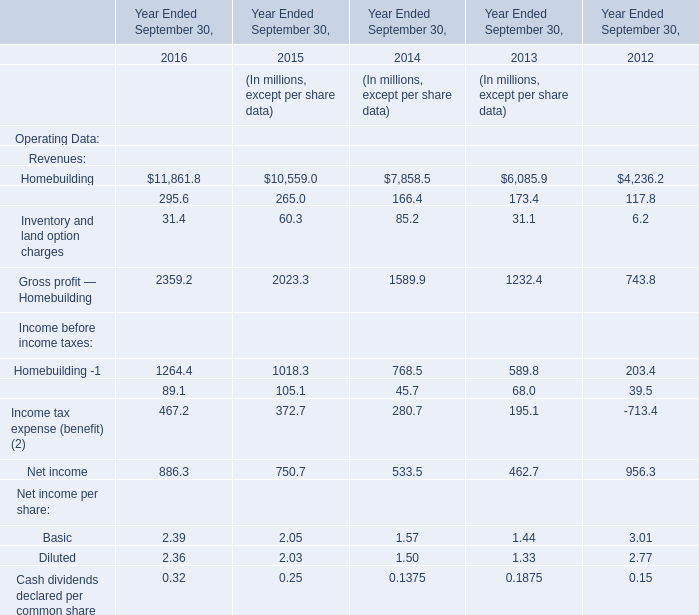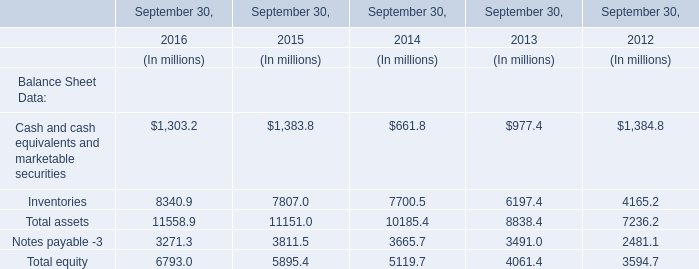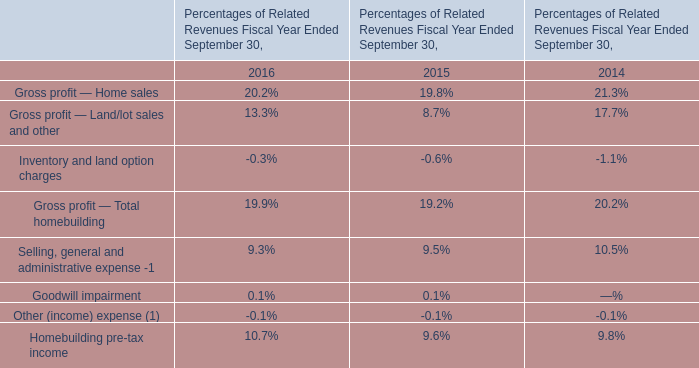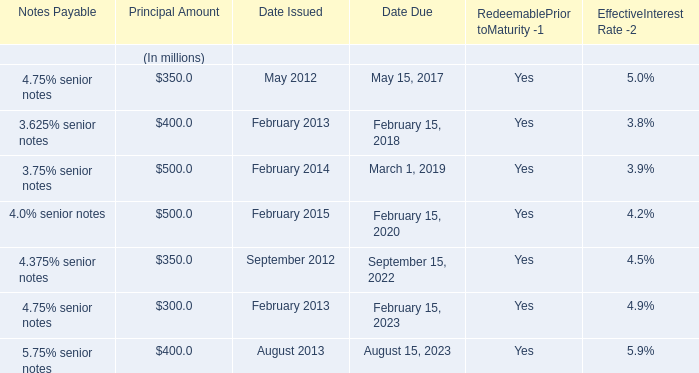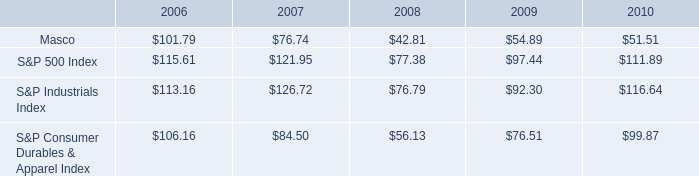what was the difference in percentage cumulative total shareholder return on masco common stock versus the s&p 500 index for the five year period ended 2010? 
Computations: (((51.51 - 100) / 100) - ((111.89 - 100) / 100))
Answer: -0.6038. 